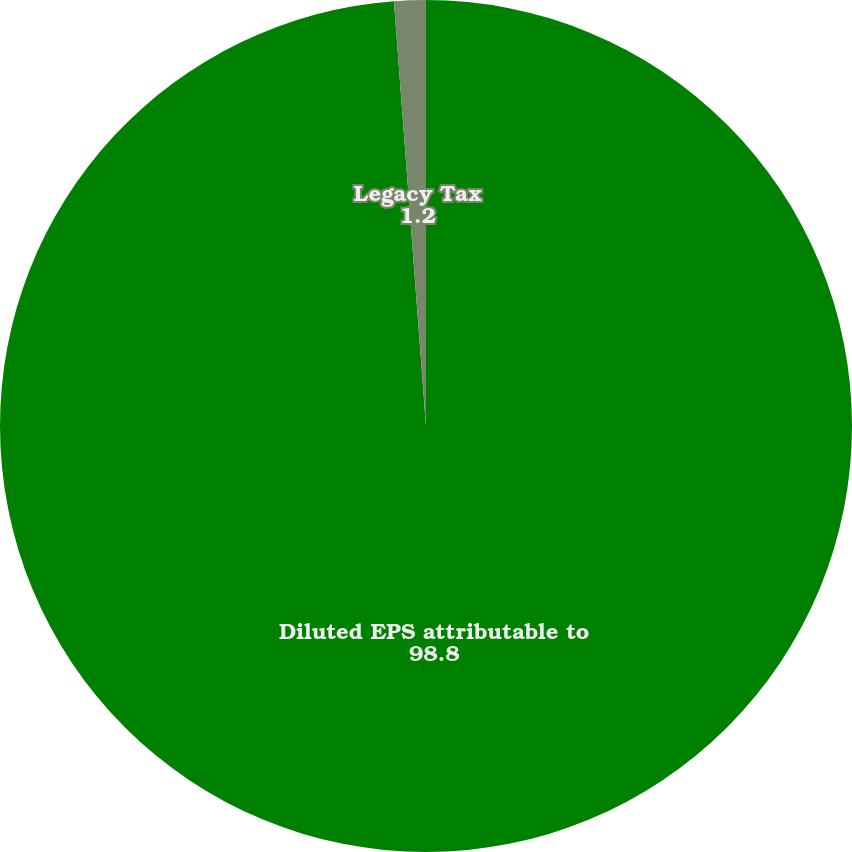<chart> <loc_0><loc_0><loc_500><loc_500><pie_chart><fcel>Diluted EPS attributable to<fcel>Legacy Tax<nl><fcel>98.8%<fcel>1.2%<nl></chart> 